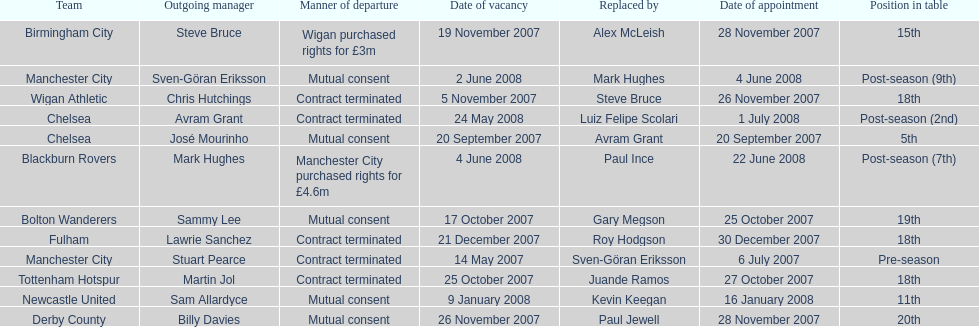Who was manager of manchester city after stuart pearce left in 2007? Sven-Göran Eriksson. 